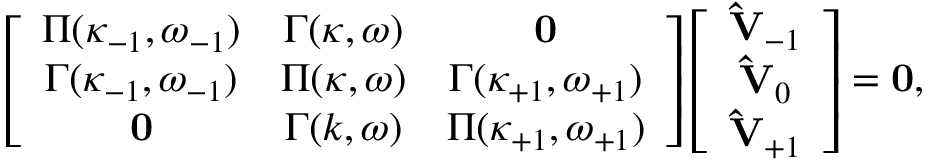Convert formula to latex. <formula><loc_0><loc_0><loc_500><loc_500>\left [ \begin{array} { c c c } { { \Pi ( \kappa _ { - 1 } , \omega _ { - 1 } ) } } & { \Gamma ( \kappa , \omega ) } & { 0 } \\ { { \Gamma ( \kappa _ { - 1 } , \omega _ { - 1 } ) } } & { \Pi ( \kappa , \omega ) } & { { \Gamma ( \kappa _ { + 1 } , \omega _ { + 1 } ) } } \\ { 0 } & { \Gamma ( k , \omega ) } & { { \Pi ( \kappa _ { + 1 } , \omega _ { + 1 } ) } } \end{array} \right ] \left [ \begin{array} { c c c } { { \hat { V } _ { - 1 } } } \\ { { \hat { V } _ { 0 } } } \\ { { \hat { V } _ { + 1 } } } \end{array} \right ] = 0 ,</formula> 